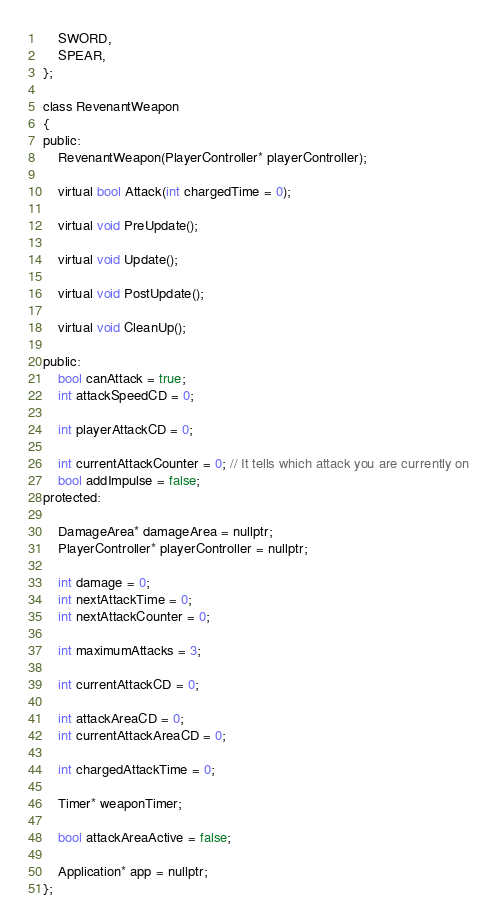<code> <loc_0><loc_0><loc_500><loc_500><_C_>	SWORD,
	SPEAR,
};

class RevenantWeapon
{
public:
	RevenantWeapon(PlayerController* playerController);

	virtual bool Attack(int chargedTime = 0);

	virtual void PreUpdate();

	virtual void Update();

	virtual void PostUpdate();

	virtual void CleanUp();

public:
	bool canAttack = true;
	int attackSpeedCD = 0;

	int playerAttackCD = 0;

	int currentAttackCounter = 0; // It tells which attack you are currently on
	bool addImpulse = false;
protected:

	DamageArea* damageArea = nullptr;
	PlayerController* playerController = nullptr;

	int damage = 0;
	int nextAttackTime = 0;
	int nextAttackCounter = 0;
	
	int maximumAttacks = 3;
	
	int currentAttackCD = 0;

	int attackAreaCD = 0;
	int currentAttackAreaCD = 0;

	int chargedAttackTime = 0;

	Timer* weaponTimer;

	bool attackAreaActive = false;

	Application* app = nullptr;
};

</code> 